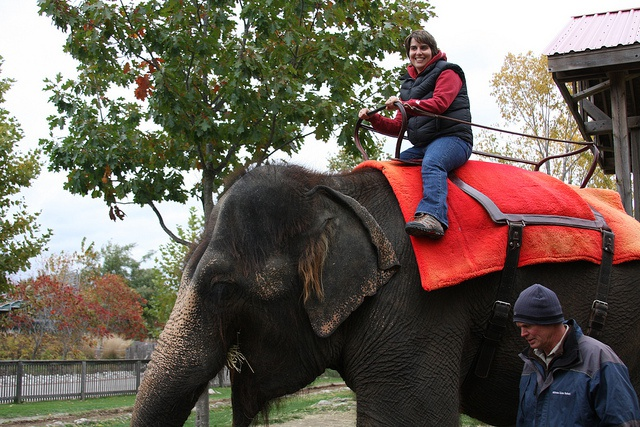Describe the objects in this image and their specific colors. I can see elephant in white, black, and gray tones, people in white, black, maroon, navy, and gray tones, and people in white, black, navy, gray, and darkblue tones in this image. 